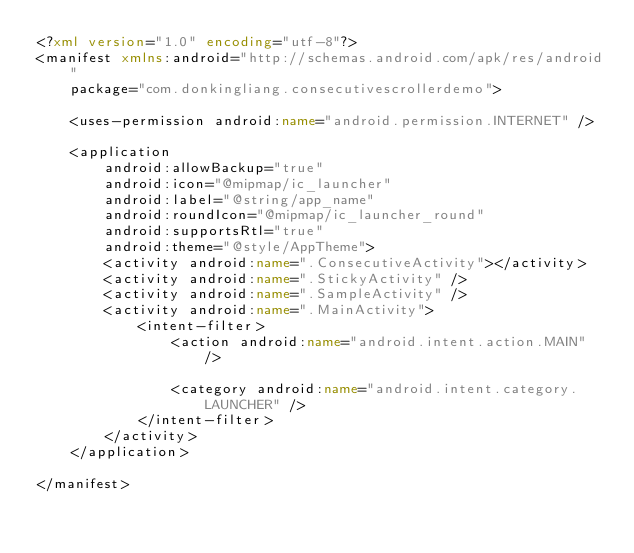<code> <loc_0><loc_0><loc_500><loc_500><_XML_><?xml version="1.0" encoding="utf-8"?>
<manifest xmlns:android="http://schemas.android.com/apk/res/android"
    package="com.donkingliang.consecutivescrollerdemo">

    <uses-permission android:name="android.permission.INTERNET" />

    <application
        android:allowBackup="true"
        android:icon="@mipmap/ic_launcher"
        android:label="@string/app_name"
        android:roundIcon="@mipmap/ic_launcher_round"
        android:supportsRtl="true"
        android:theme="@style/AppTheme">
        <activity android:name=".ConsecutiveActivity"></activity>
        <activity android:name=".StickyActivity" />
        <activity android:name=".SampleActivity" />
        <activity android:name=".MainActivity">
            <intent-filter>
                <action android:name="android.intent.action.MAIN" />

                <category android:name="android.intent.category.LAUNCHER" />
            </intent-filter>
        </activity>
    </application>

</manifest></code> 